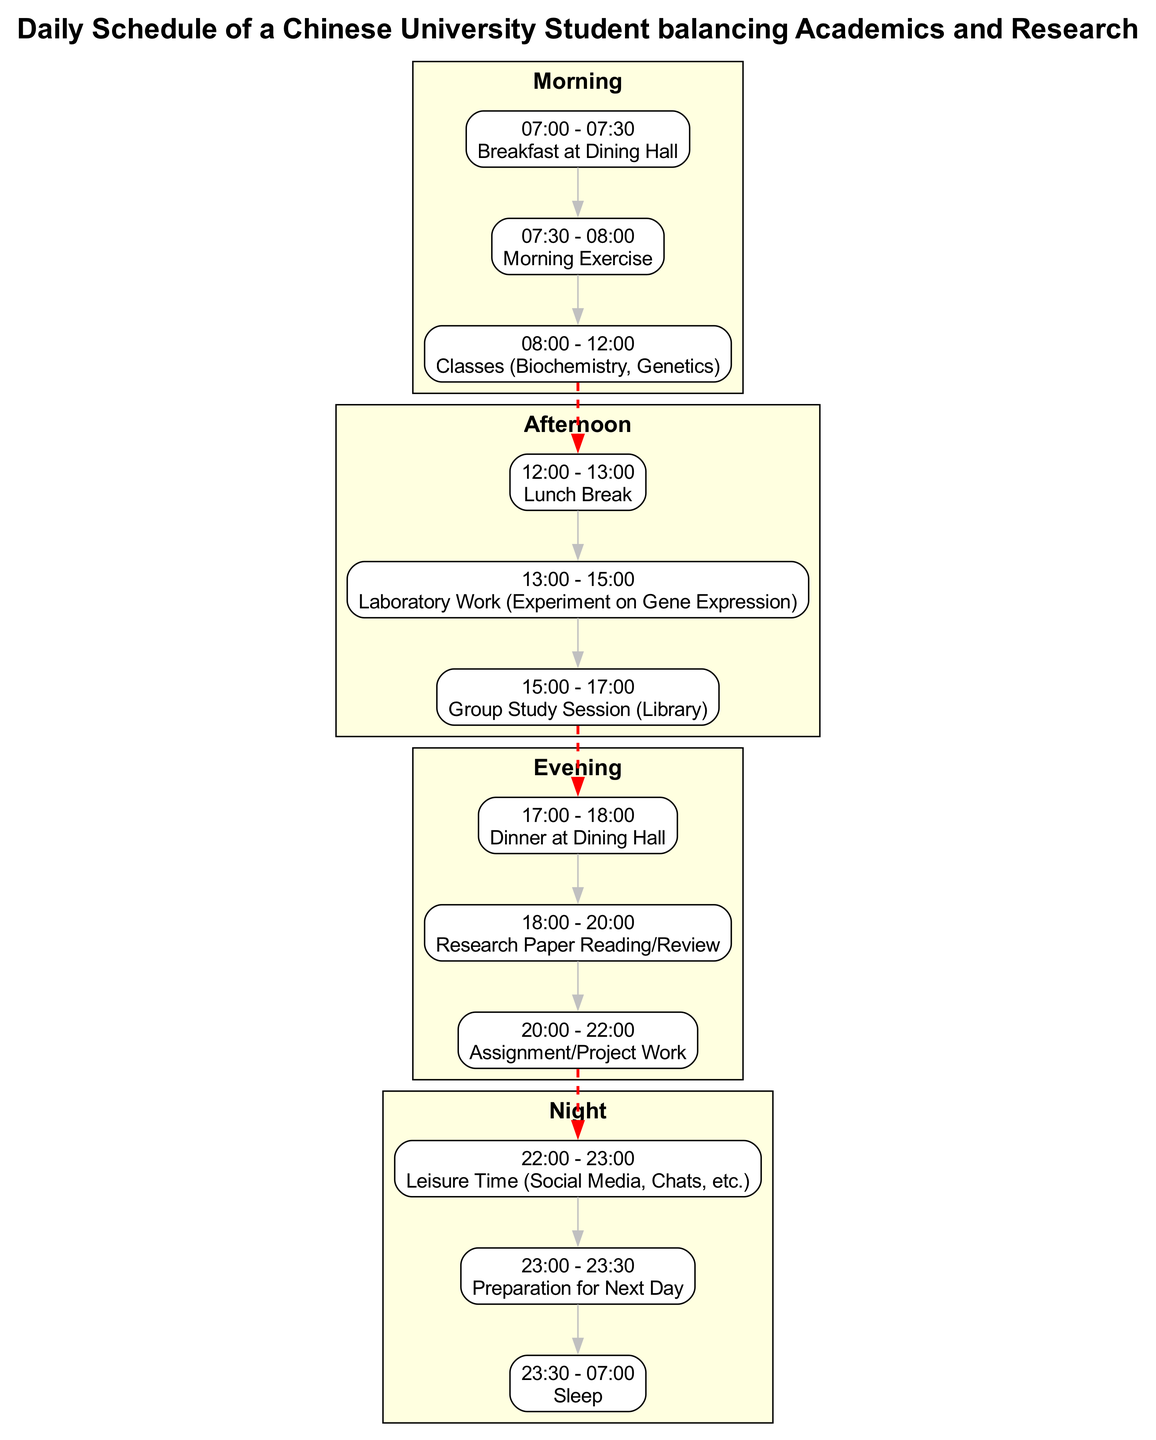What activities are scheduled in the morning block? The morning block includes three activities: "Breakfast at Dining Hall," "Morning Exercise," and "Classes (Biochemistry, Genetics)." Each of these activities is listed under the morning section in the diagram.
Answer: Breakfast at Dining Hall, Morning Exercise, Classes (Biochemistry, Genetics) How many activities are listed in the evening block? The evening block lists three activities: "Dinner at Dining Hall," "Research Paper Reading/Review," and "Assignment/Project Work." Counting these activities gives a total of three for the evening block.
Answer: 3 What time does "Group Study Session (Library)" take place? This activity is assigned to the afternoon block and is scheduled from 15:00 to 17:00, as indicated in the diagram.
Answer: 15:00 - 17:00 What is the transition between the afternoon and evening blocks? The transition is represented by a dashed red edge that connects the last activity of the afternoon block ("Group Study Session (Library)") to the first activity of the evening block ("Dinner at Dining Hall"). This visually indicates the end of afternoon activities and the start of evening activities.
Answer: Dinner at Dining Hall Which activity follows "Leisure Time (Social Media, Chats, etc.)"? The activity that follows "Leisure Time (Social Media, Chats, etc.)" is "Preparation for Next Day." This is shown as the next node in the night block sequence of activities.
Answer: Preparation for Next Day What is the total duration of sleep in this daily schedule? The sleep activity spans from 23:30 to 07:00, which amounts to 7.5 hours of sleep. This can be calculated by determining the time difference between the start and end of that activity.
Answer: 7.5 hours Which block has the most activities scheduled? Upon reviewing the blocks, the afternoon block contains three activities, the same as the evening block. Meanwhile, the morning block also has three activities, but none exceed three. Therefore, all blocks are equal when it comes to the number of scheduled activities.
Answer: All blocks have the same number of activities What time does the last activity of the night block end? The last activity in the night block is "Sleep," which ends at 07:00 according to the schedule in the diagram.
Answer: 07:00 